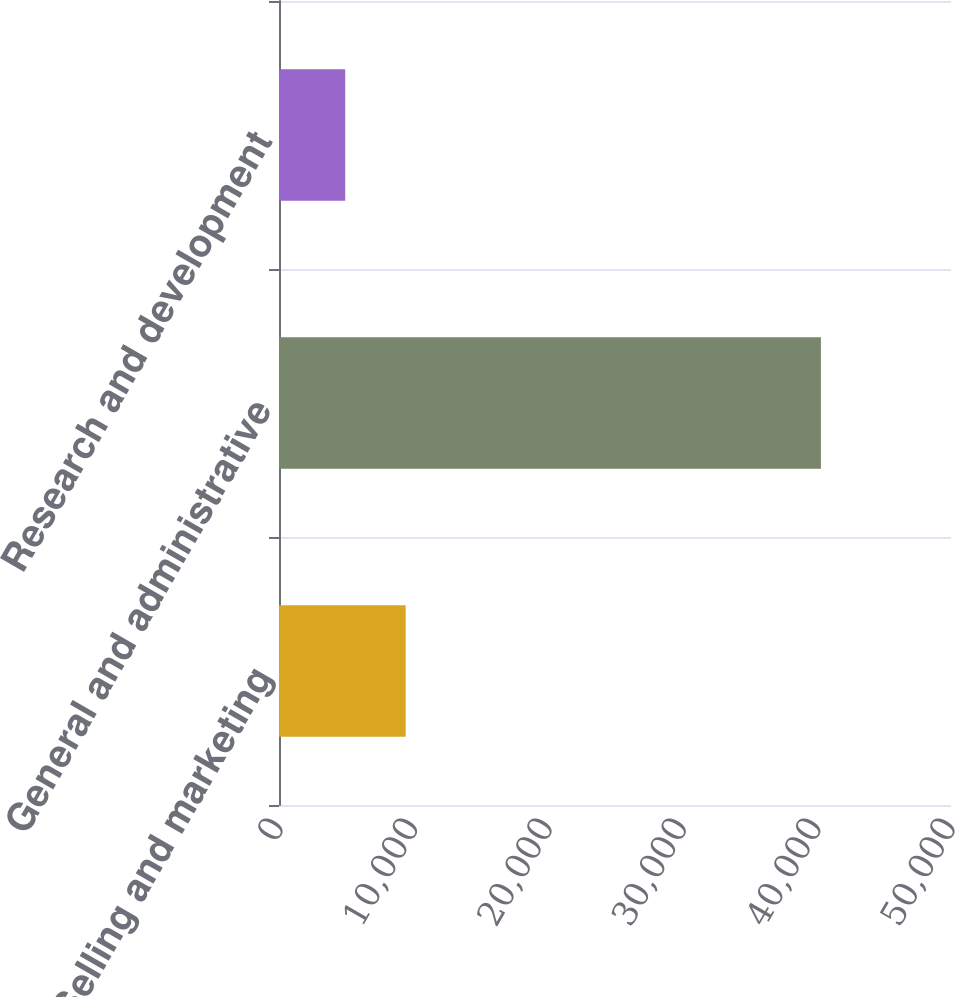<chart> <loc_0><loc_0><loc_500><loc_500><bar_chart><fcel>Selling and marketing<fcel>General and administrative<fcel>Research and development<nl><fcel>9425<fcel>40322<fcel>4926<nl></chart> 